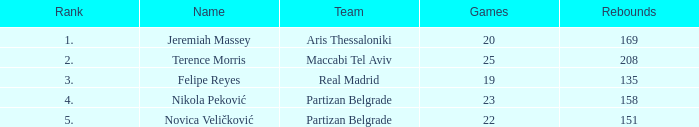What is the number of Games for Partizan Belgrade player Nikola Peković with a Rank of more than 4? None. 